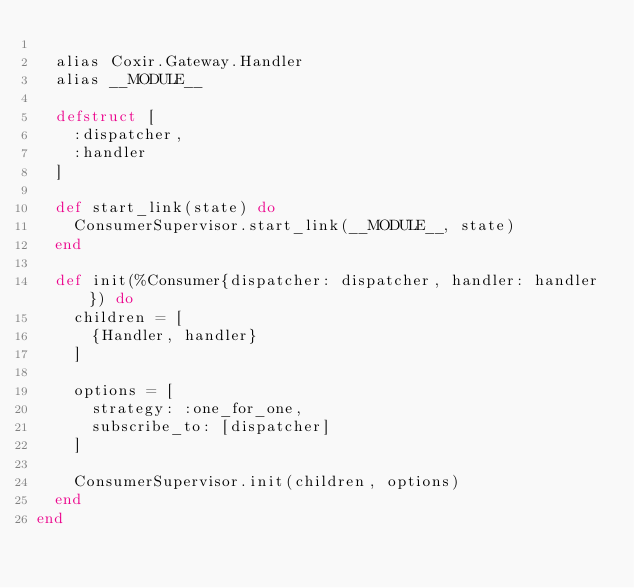Convert code to text. <code><loc_0><loc_0><loc_500><loc_500><_Elixir_>
  alias Coxir.Gateway.Handler
  alias __MODULE__

  defstruct [
    :dispatcher,
    :handler
  ]

  def start_link(state) do
    ConsumerSupervisor.start_link(__MODULE__, state)
  end

  def init(%Consumer{dispatcher: dispatcher, handler: handler}) do
    children = [
      {Handler, handler}
    ]

    options = [
      strategy: :one_for_one,
      subscribe_to: [dispatcher]
    ]

    ConsumerSupervisor.init(children, options)
  end
end
</code> 